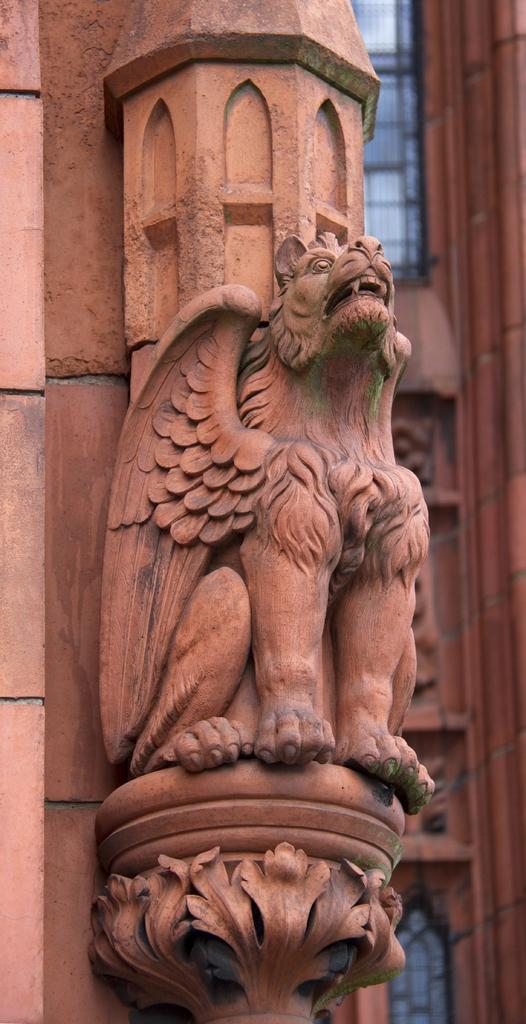What is the main subject of the image? There is a sculpture in the image. Can you describe the background of the image? There is a building with windows in the background of the image. What type of key is the girl using to unlock the door in the image? There is no girl or key present in the image; it features a sculpture and a building with windows in the background. 